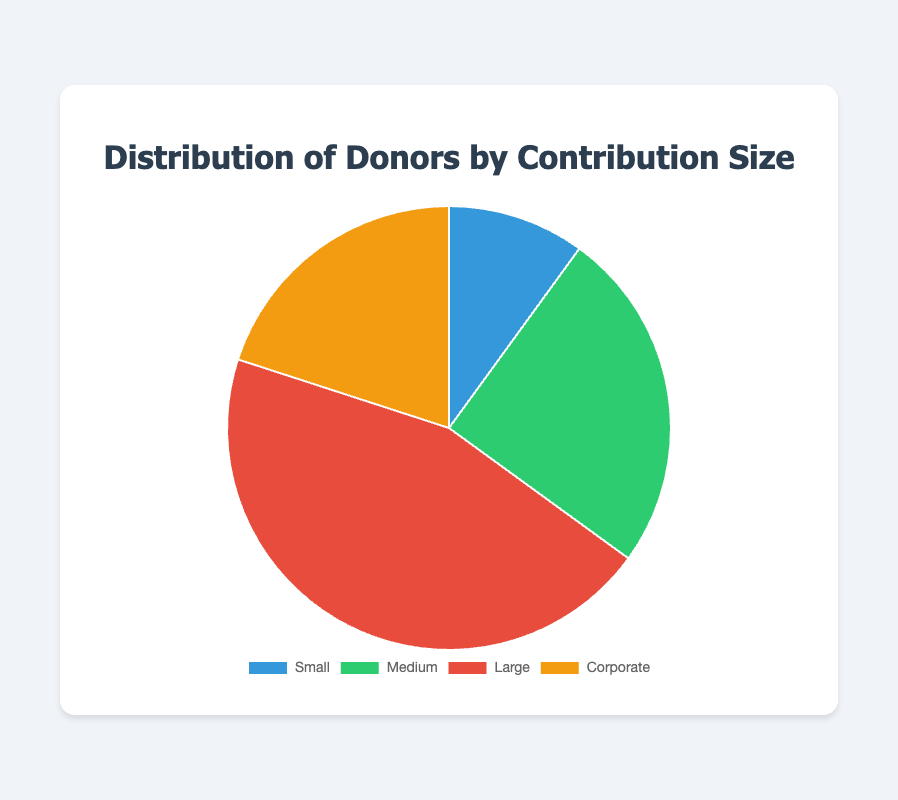Which donor type contributed the highest percentage? From the pie chart, the segment for "Large" donors is the biggest, occupying 45% of the chart, which is the highest percentage.
Answer: Large Which donor type contributed the lowest percentage? From the pie chart, the "Small" donors segment is the smallest, representing 10% of the chart, which is the lowest percentage.
Answer: Small By how much does the percentage of contributions from Corporate donors exceed the percentage from Small donors? The "Corporate" donors contribute 20% and the "Small" donors contribute 10%. The difference between their contributions is 20% - 10% = 10%.
Answer: 10% What percentage of contributions come from Medium and Corporate donors combined? Adding the percentage contributions of "Medium" (25%) and "Corporate" (20%) donors gives 25% + 20% = 45%.
Answer: 45% Which color represents the contributions from Large donors? From the pie chart, the segment representing "Large" donors is colored red.
Answer: Red Compare the contributions from Medium and Large donors. Which is greater, and by how much percentage? The "Large" donors contribute 45% whereas the "Medium" donors contribute 25%. The difference is 45% - 25% = 20%.
Answer: Large, 20% If you combine the contributions from Small, Medium, and Corporate donors, does their total contribution exceed that of Large donors? By how much or how little? Adding the percentages of "Small" (10%), "Medium" (25%), and "Corporate" (20%) gives 10% + 25% + 20% = 55%. Since "Large" donors contribute 45%, 55% - 45% = 10% which means the combined contribution is 10% more than that of Large donors.
Answer: Yes, by 10% What's the total contribution percentage for donors other than Small donors? Summing up the contribution percentages for "Medium" (25%), "Large" (45%), and "Corporate" (20%) gives 25% + 45% + 20% = 90%.
Answer: 90% 